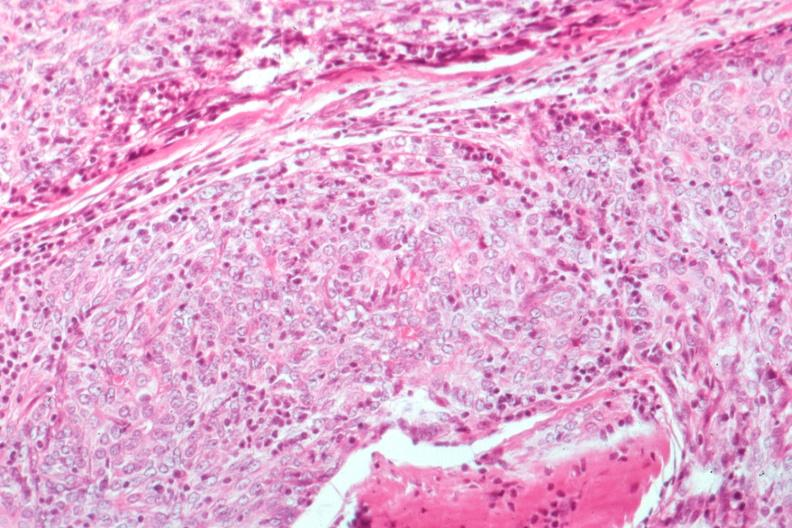s thymus present?
Answer the question using a single word or phrase. Yes 